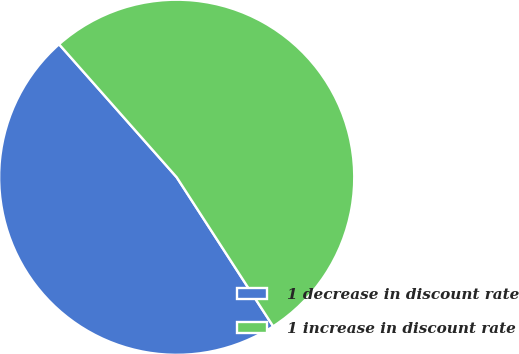<chart> <loc_0><loc_0><loc_500><loc_500><pie_chart><fcel>1 decrease in discount rate<fcel>1 increase in discount rate<nl><fcel>47.62%<fcel>52.38%<nl></chart> 